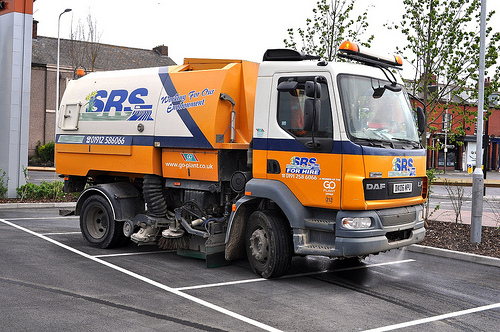<image>
Can you confirm if the truck is next to the road? No. The truck is not positioned next to the road. They are located in different areas of the scene. 